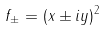Convert formula to latex. <formula><loc_0><loc_0><loc_500><loc_500>f _ { \pm } = ( x \pm i y ) ^ { 2 }</formula> 